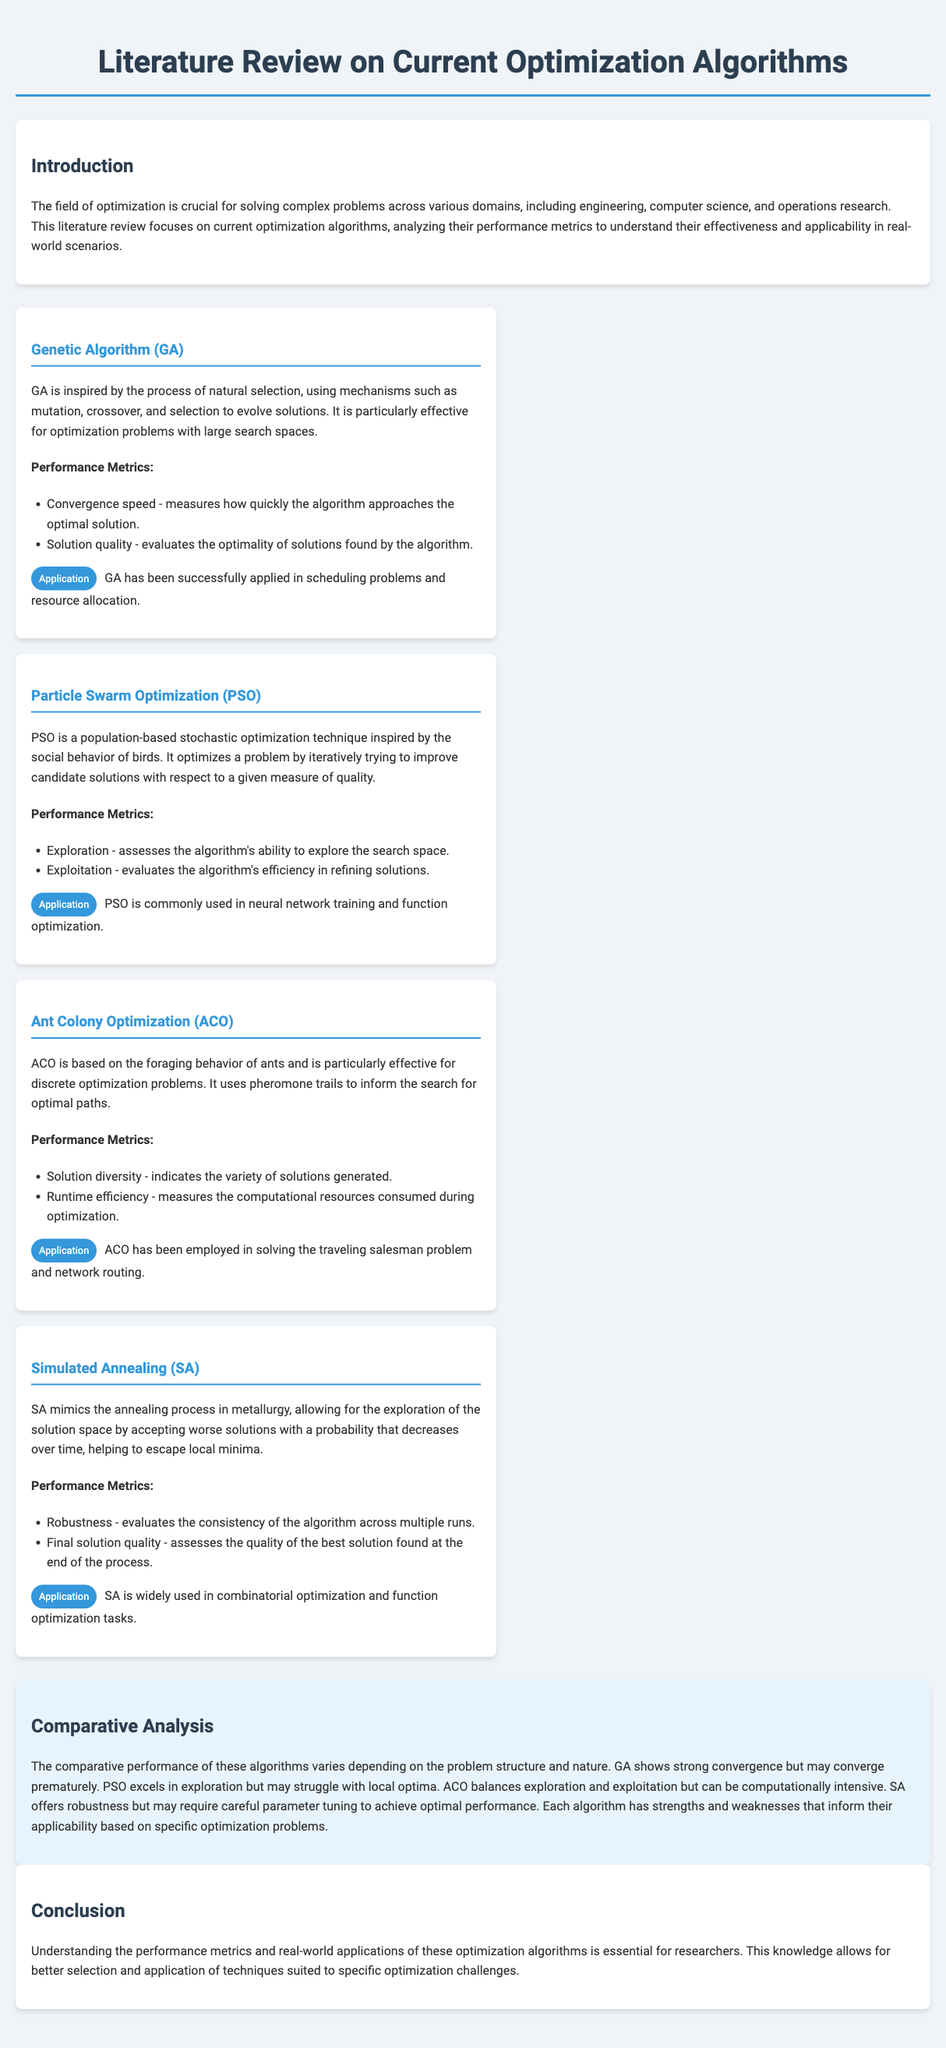What is the main focus of this literature review? The main focus is on current optimization algorithms and their performance metrics.
Answer: Current optimization algorithms What is the inspiration behind the Genetic Algorithm? The Genetic Algorithm is inspired by the process of natural selection.
Answer: Natural selection Which performance metric does Particle Swarm Optimization primarily assess for improvement? Particle Swarm Optimization assesses the algorithm's ability to explore the search space.
Answer: Exploration What discrete problem is Ant Colony Optimization particularly effective in solving? Ant Colony Optimization is particularly effective in solving the traveling salesman problem.
Answer: Traveling salesman problem What does the robustness metric measure in Simulated Annealing? The robustness metric evaluates the consistency of the algorithm across multiple runs.
Answer: Consistency Which algorithm shows strong convergence but may converge prematurely? Genetic Algorithm shows strong convergence but may converge prematurely.
Answer: Genetic Algorithm In terms of computational resources, which algorithm may be computationally intensive? Ant Colony Optimization can be computationally intensive.
Answer: Ant Colony Optimization What aspect of solution quality does the final solution quality metric evaluate in Simulated Annealing? The final solution quality metric assesses the quality of the best solution found.
Answer: Quality of the best solution 